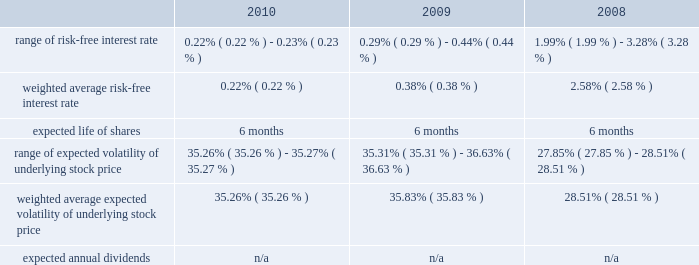American tower corporation and subsidiaries notes to consolidated financial statements as of december 31 , 2010 , total unrecognized compensation expense related to unvested restricted stock units granted under the 2007 plan was $ 57.5 million and is expected to be recognized over a weighted average period of approximately two years .
Employee stock purchase plan 2014the company maintains an employee stock purchase plan ( 201cespp 201d ) for all eligible employees .
Under the espp , shares of the company 2019s common stock may be purchased during bi-annual offering periods at 85% ( 85 % ) of the lower of the fair market value on the first or the last day of each offering period .
Employees may purchase shares having a value not exceeding 15% ( 15 % ) of their gross compensation during an offering period and may not purchase more than $ 25000 worth of stock in a calendar year ( based on market values at the beginning of each offering period ) .
The offering periods run from june 1 through november 30 and from december 1 through may 31 of each year .
During the 2010 , 2009 and 2008 offering periods employees purchased 75354 , 77509 and 55764 shares , respectively , at weighted average prices per share of $ 34.16 , $ 23.91 and $ 30.08 , respectively .
The fair value of the espp offerings is estimated on the offering period commencement date using a black-scholes pricing model with the expense recognized over the expected life , which is the six month offering period over which employees accumulate payroll deductions to purchase the company 2019s common stock .
The weighted average fair value for the espp shares purchased during 2010 , 2009 and 2008 was $ 9.43 , $ 6.65 and $ 7.89 , respectively .
At december 31 , 2010 , 8.7 million shares remain reserved for future issuance under the plan .
Key assumptions used to apply this pricing model for the years ended december 31 , are as follows: .
13 .
Stockholders 2019 equity warrants 2014in august 2005 , the company completed its merger with spectrasite , inc .
And assumed outstanding warrants to purchase shares of spectrasite , inc .
Common stock .
As of the merger completion date , each warrant was exercisable for two shares of spectrasite , inc .
Common stock at an exercise price of $ 32 per warrant .
Upon completion of the merger , each warrant to purchase shares of spectrasite , inc .
Common stock automatically converted into a warrant to purchase shares of the company 2019s common stock , such that upon exercise of each warrant , the holder has a right to receive 3.575 shares of the company 2019s common stock in lieu of each share of spectrasite , inc .
Common stock that would have been receivable under each assumed warrant prior to the merger .
Upon completion of the company 2019s merger with spectrasite , inc. , these warrants were exercisable for approximately 6.8 million shares of common stock .
Of these warrants , warrants to purchase approximately none and 1.7 million shares of common stock remained outstanding as of december 31 , 2010 and 2009 , respectively .
These warrants expired on february 10 , 2010 .
Stock repurchase program 2014during the year ended december 31 , 2010 , the company repurchased an aggregate of approximately 9.3 million shares of its common stock for an aggregate of $ 420.8 million , including commissions and fees , of which $ 418.6 million was paid in cash prior to december 31 , 2010 and $ 2.2 million was included in accounts payable and accrued expenses in the accompanying consolidated balance sheet as of december 31 , 2010 , pursuant to its publicly announced stock repurchase program , as described below. .
What is the total cash received from shares purchased from employees during 2009 , in millions? 
Computations: ((77509 * 23.91) / 1000000)
Answer: 1.85324. 